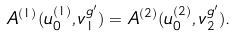Convert formula to latex. <formula><loc_0><loc_0><loc_500><loc_500>A ^ { ( 1 ) } ( u _ { 0 } ^ { ( 1 ) } , v _ { 1 } ^ { g ^ { \prime } } ) = A ^ { ( 2 ) } ( u _ { 0 } ^ { ( 2 ) } , v _ { 2 } ^ { g ^ { \prime } } ) .</formula> 